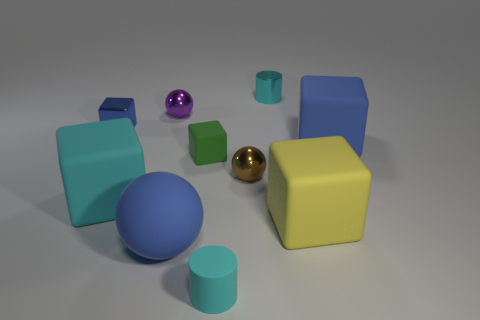Are there an equal number of tiny rubber cubes that are on the right side of the small purple ball and big cyan things that are to the left of the large blue rubber block?
Offer a terse response. Yes. There is a small shiny thing on the left side of the purple sphere; what shape is it?
Your answer should be compact. Cube. What is the shape of the blue thing that is the same size as the green thing?
Your answer should be compact. Cube. What color is the tiny cube that is left of the big matte thing left of the small sphere that is left of the green rubber block?
Make the answer very short. Blue. Do the green object and the tiny brown metal thing have the same shape?
Offer a very short reply. No. Are there the same number of blue spheres that are to the right of the big yellow cube and shiny blocks?
Keep it short and to the point. No. How many other objects are there of the same material as the tiny blue object?
Your answer should be compact. 3. There is a cyan rubber object that is to the left of the big rubber ball; is it the same size as the cyan cylinder in front of the yellow matte thing?
Make the answer very short. No. What number of things are blue blocks that are on the right side of the brown thing or metal spheres that are behind the tiny blue thing?
Provide a short and direct response. 2. Is the color of the metallic thing that is to the left of the small purple metallic object the same as the matte cube that is behind the small green object?
Offer a very short reply. Yes. 